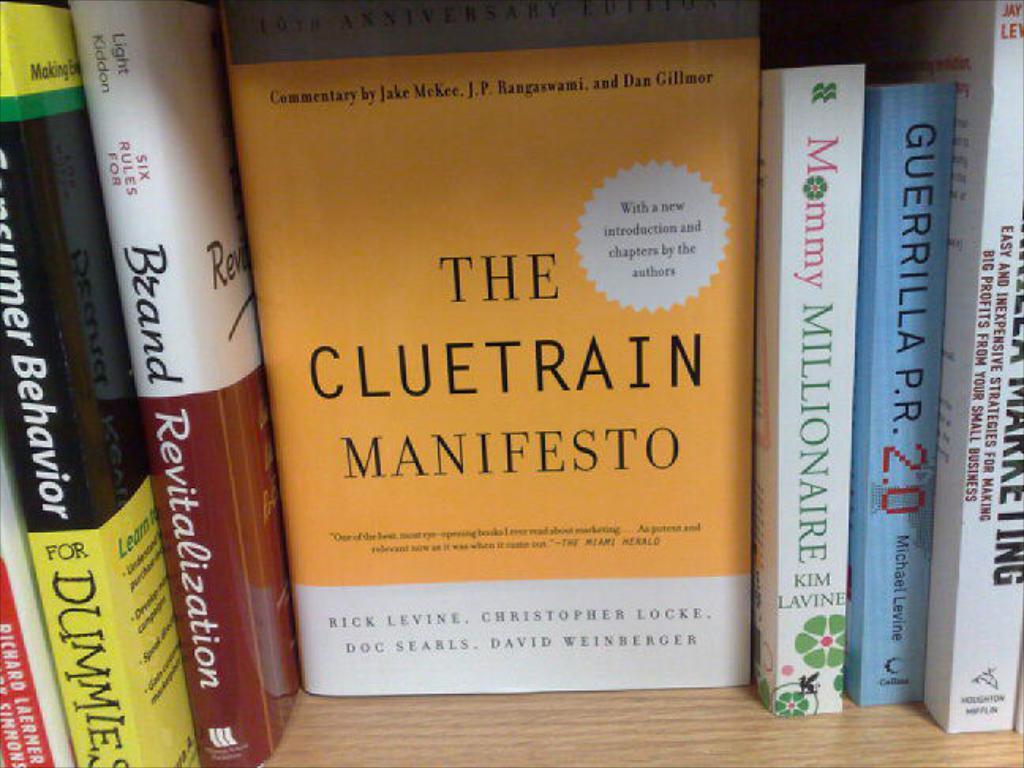According to the white starburst on it's cover, what is new about this edition of "the cluetrain manifesto?
Offer a very short reply. Introduction and chapters. 